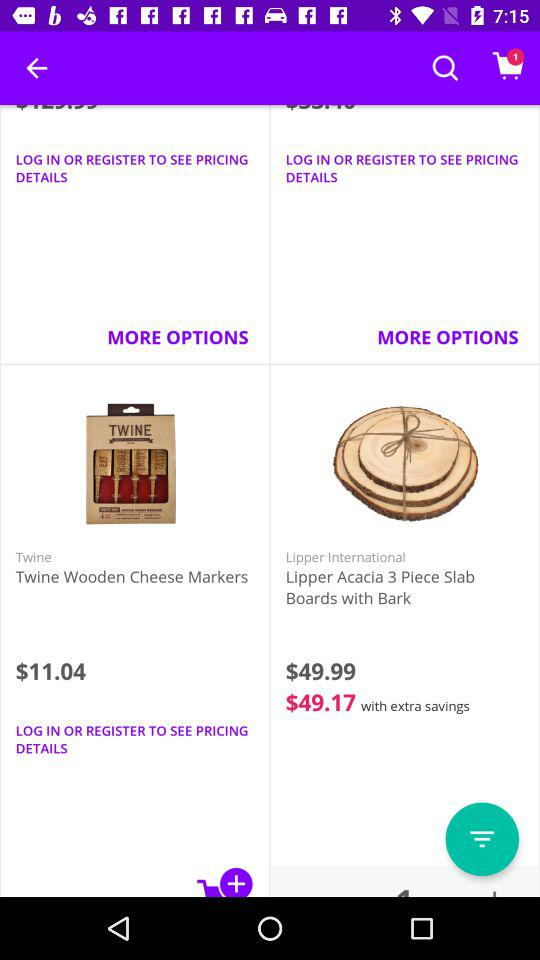What is the price of twine wooden cheese makers? The price is $11.04. 